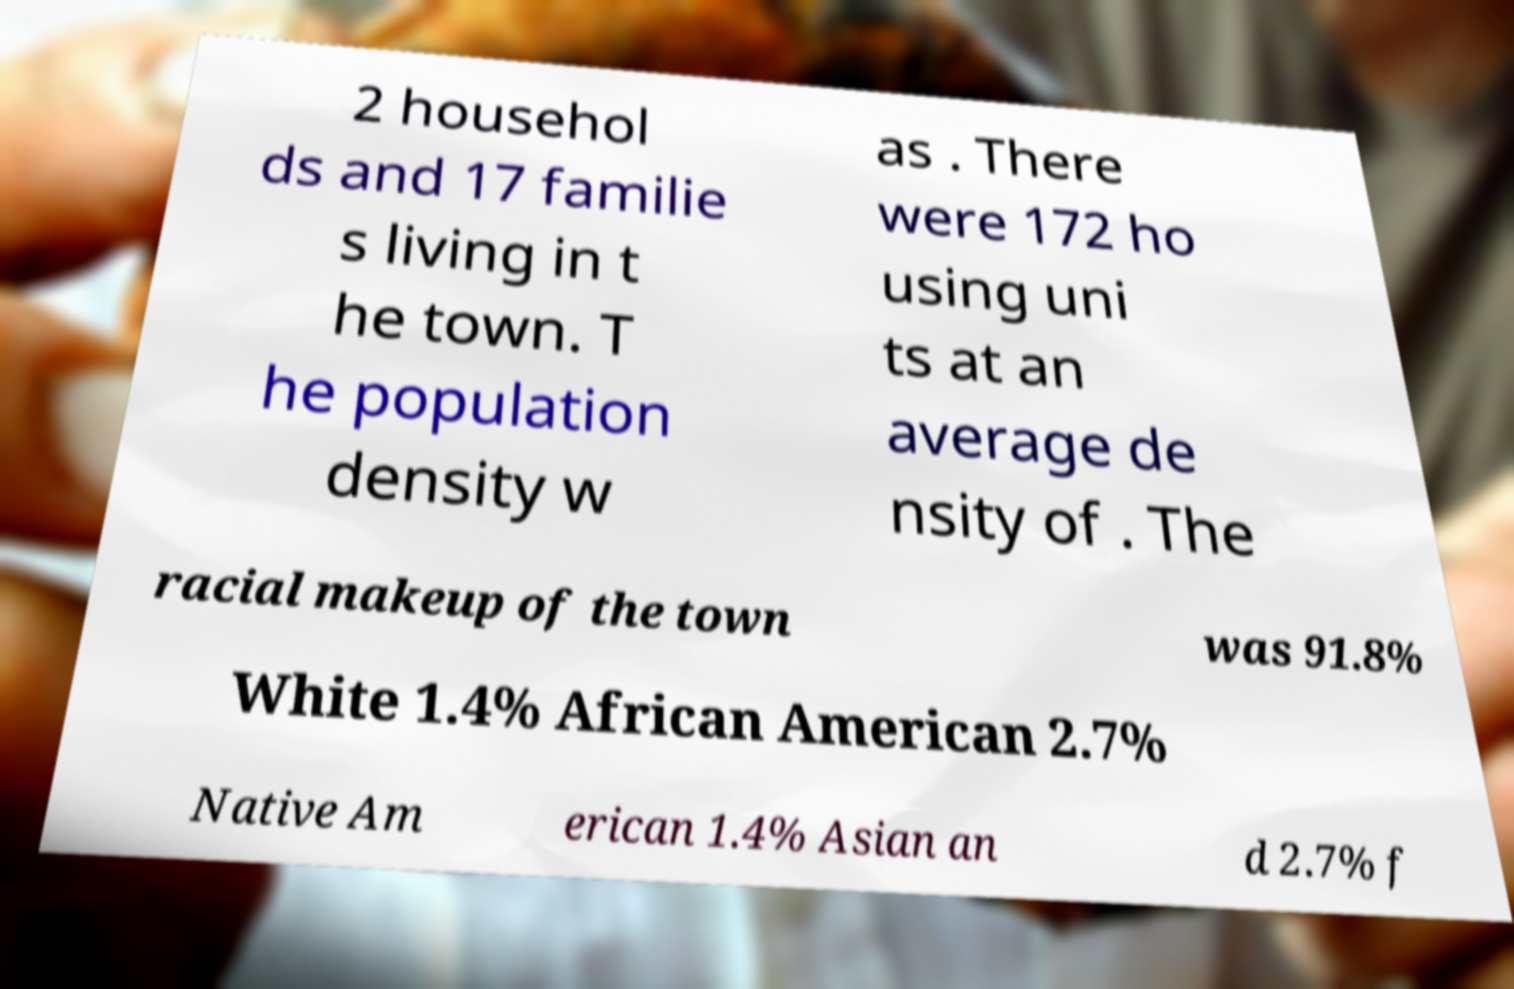I need the written content from this picture converted into text. Can you do that? 2 househol ds and 17 familie s living in t he town. T he population density w as . There were 172 ho using uni ts at an average de nsity of . The racial makeup of the town was 91.8% White 1.4% African American 2.7% Native Am erican 1.4% Asian an d 2.7% f 